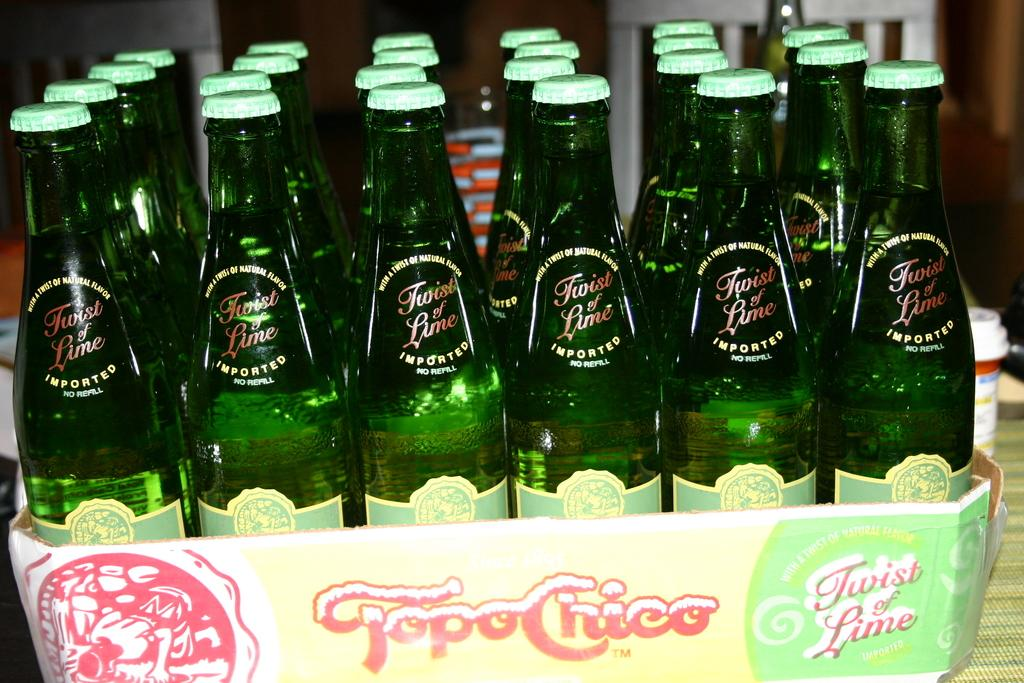<image>
Create a compact narrative representing the image presented. a case of Topo-Chico Twist of Lime drink on a table 